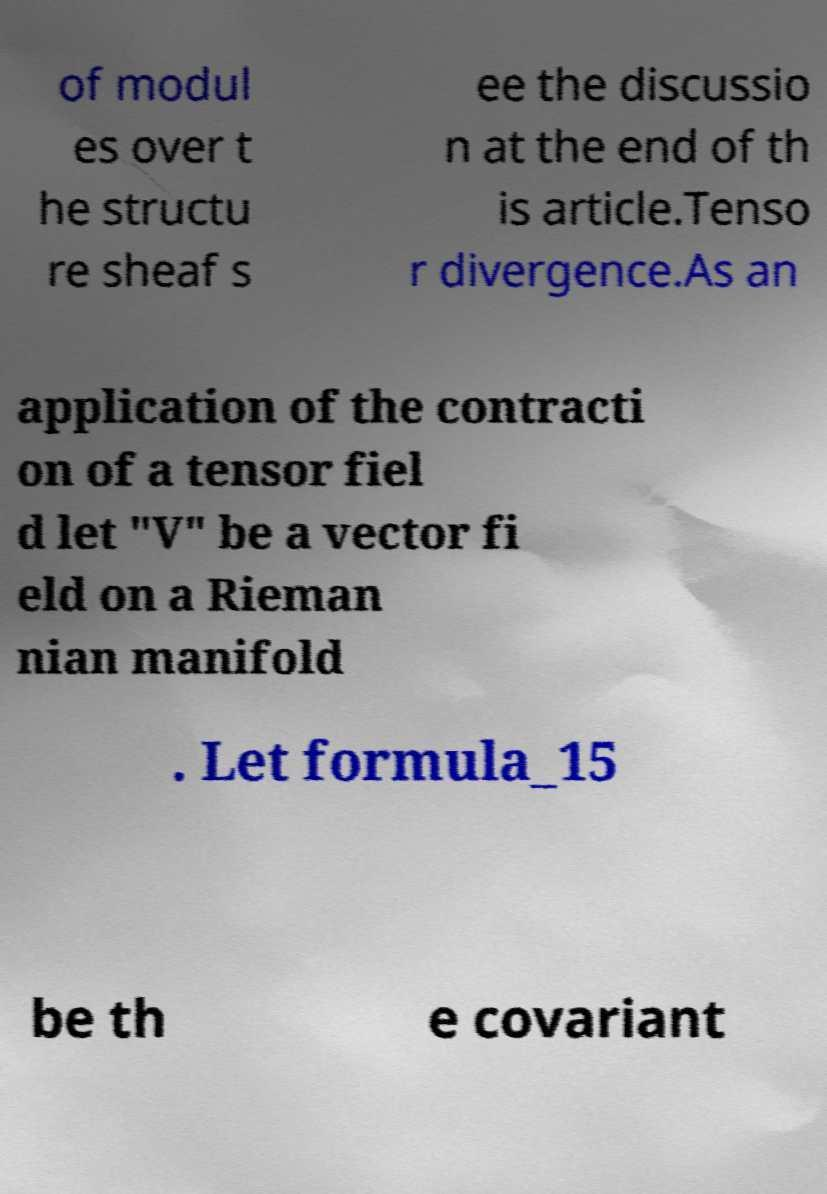There's text embedded in this image that I need extracted. Can you transcribe it verbatim? of modul es over t he structu re sheaf s ee the discussio n at the end of th is article.Tenso r divergence.As an application of the contracti on of a tensor fiel d let "V" be a vector fi eld on a Rieman nian manifold . Let formula_15 be th e covariant 